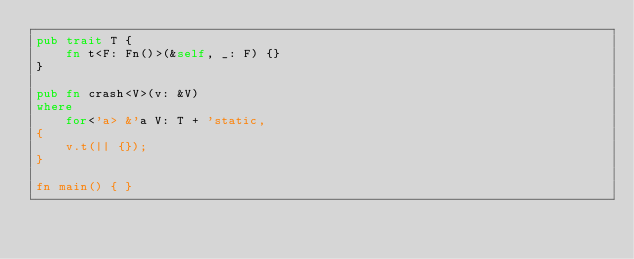<code> <loc_0><loc_0><loc_500><loc_500><_Rust_>pub trait T {
    fn t<F: Fn()>(&self, _: F) {}
}

pub fn crash<V>(v: &V)
where
    for<'a> &'a V: T + 'static,
{
    v.t(|| {});
}

fn main() { }
</code> 